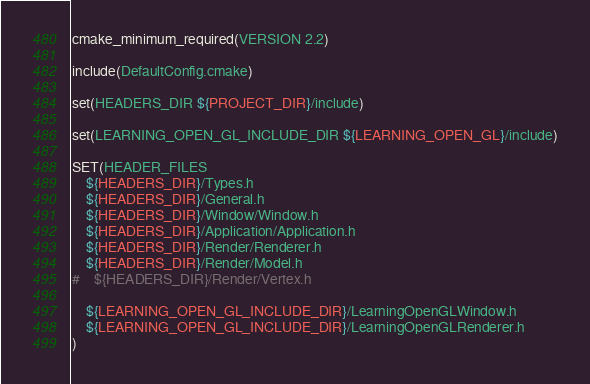<code> <loc_0><loc_0><loc_500><loc_500><_CMake_>cmake_minimum_required(VERSION 2.2)

include(DefaultConfig.cmake)

set(HEADERS_DIR ${PROJECT_DIR}/include)

set(LEARNING_OPEN_GL_INCLUDE_DIR ${LEARNING_OPEN_GL}/include)

SET(HEADER_FILES
    ${HEADERS_DIR}/Types.h
    ${HEADERS_DIR}/General.h
    ${HEADERS_DIR}/Window/Window.h
    ${HEADERS_DIR}/Application/Application.h
    ${HEADERS_DIR}/Render/Renderer.h
    ${HEADERS_DIR}/Render/Model.h
#    ${HEADERS_DIR}/Render/Vertex.h

    ${LEARNING_OPEN_GL_INCLUDE_DIR}/LearningOpenGLWindow.h
    ${LEARNING_OPEN_GL_INCLUDE_DIR}/LearningOpenGLRenderer.h
)
</code> 